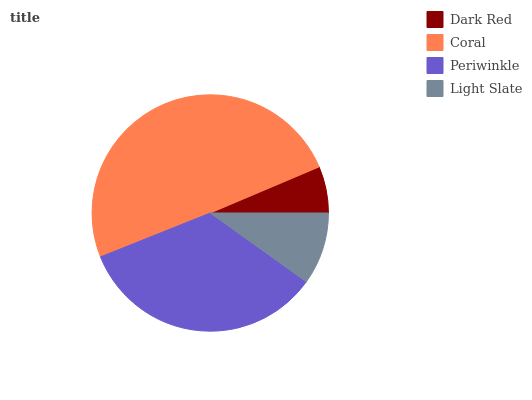Is Dark Red the minimum?
Answer yes or no. Yes. Is Coral the maximum?
Answer yes or no. Yes. Is Periwinkle the minimum?
Answer yes or no. No. Is Periwinkle the maximum?
Answer yes or no. No. Is Coral greater than Periwinkle?
Answer yes or no. Yes. Is Periwinkle less than Coral?
Answer yes or no. Yes. Is Periwinkle greater than Coral?
Answer yes or no. No. Is Coral less than Periwinkle?
Answer yes or no. No. Is Periwinkle the high median?
Answer yes or no. Yes. Is Light Slate the low median?
Answer yes or no. Yes. Is Dark Red the high median?
Answer yes or no. No. Is Periwinkle the low median?
Answer yes or no. No. 